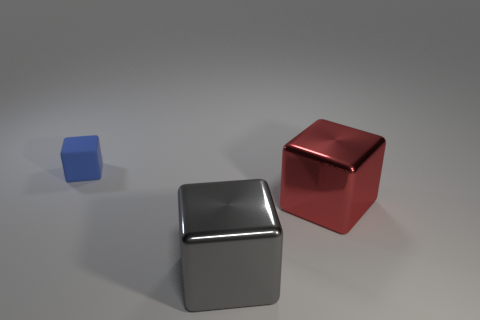How does the size of the blue cube compare to the other two cubes? The blue cube is considerably smaller than both the gray and red cubes. Its edges are shorter in length, and its overall volume is less, giving it a miniature appearance next to the others. 